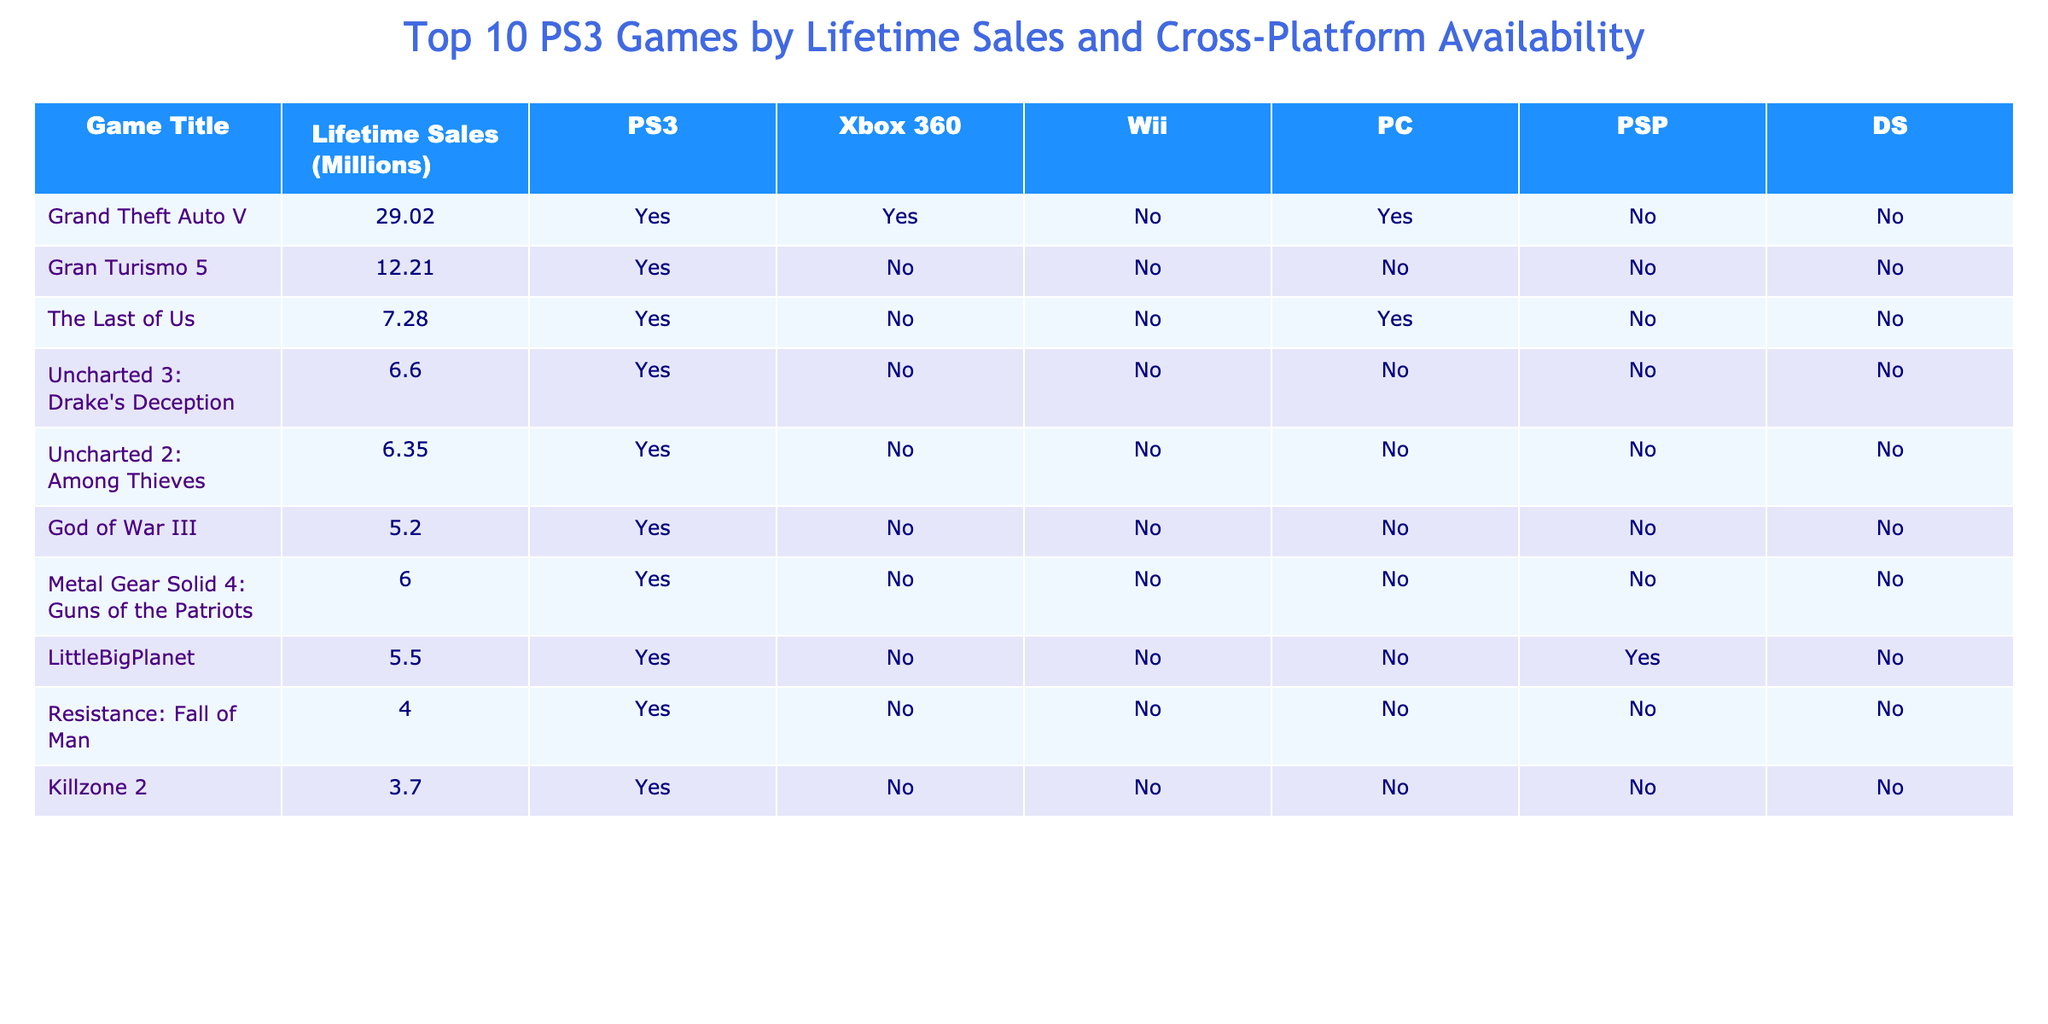What is the lifetime sales of Gran Turismo 5? The table lists Gran Turismo 5 under the Game Title column, and its corresponding Lifetime Sales (Millions) column shows a value of 12.21.
Answer: 12.21 million Which game has the highest lifetime sales? By examining the Lifetime Sales column, Grand Theft Auto V has the highest value at 29.02 million.
Answer: Grand Theft Auto V How many games are available on both PS3 and Xbox 360? Checking the columns for PS3 and Xbox 360, the games that have a "Yes" in both columns are Grand Theft Auto V, so there is only one game.
Answer: 1 game Is LittleBigPlanet available on PC? The table shows that LittleBigPlanet has "Yes" under PS3 but "No" under PC, indicating it is not available on PC.
Answer: No What is the difference in lifetime sales between The Last of Us and Uncharted 2: Among Thieves? The Last of Us has lifetime sales of 7.28 million, and Uncharted 2: Among Thieves has 6.35 million. The difference is 7.28 - 6.35 = 0.93 million.
Answer: 0.93 million Which game(s) are exclusive to the PS3? A game is exclusive to the PS3 if it has "Yes" under PS3 and "No" under all other platforms. Analyzing the table, all listed games except LittleBigPlanet fit this criterion. Therefore, those games are Gran Turismo 5, The Last of Us, Uncharted 3: Drake's Deception, Uncharted 2: Among Thieves, God of War III, Metal Gear Solid 4: Guns of the Patriots, Resistance: Fall of Man, and Killzone 2.
Answer: 8 games What is the total lifetime sales of all the PS3 exclusive games listed? The lifetime sales of the PS3 exclusive games are: Gran Turismo 5 (12.21), The Last of Us (7.28), Uncharted 3: Drake's Deception (6.60), Uncharted 2: Among Thieves (6.35), God of War III (5.20), Metal Gear Solid 4: Guns of the Patriots (6.00), Resistance: Fall of Man (4.00), and Killzone 2 (3.70). Summing these yields 12.21 + 7.28 + 6.60 + 6.35 + 5.20 + 6.00 + 4.00 + 3.70 = 51.34 million.
Answer: 51.34 million How many games have lifetime sales greater than 5 million? By looking at the Lifetime Sales column, the games with sales greater than 5 million are Grand Theft Auto V, Gran Turismo 5, The Last of Us, and Uncharted 3: Drake's Deception. Counting these gives 4 games.
Answer: 4 games Which game has the lowest lifetime sales, and what is that value? Scanning the Lifetime Sales column, the game with the lowest sales is Killzone 2, which has lifetime sales of 3.70 million.
Answer: Killzone 2, 3.70 million Are there any games available on the Wii? The table shows a "No" under Wii for all listed games, indicating there are no games available on that platform.
Answer: No 